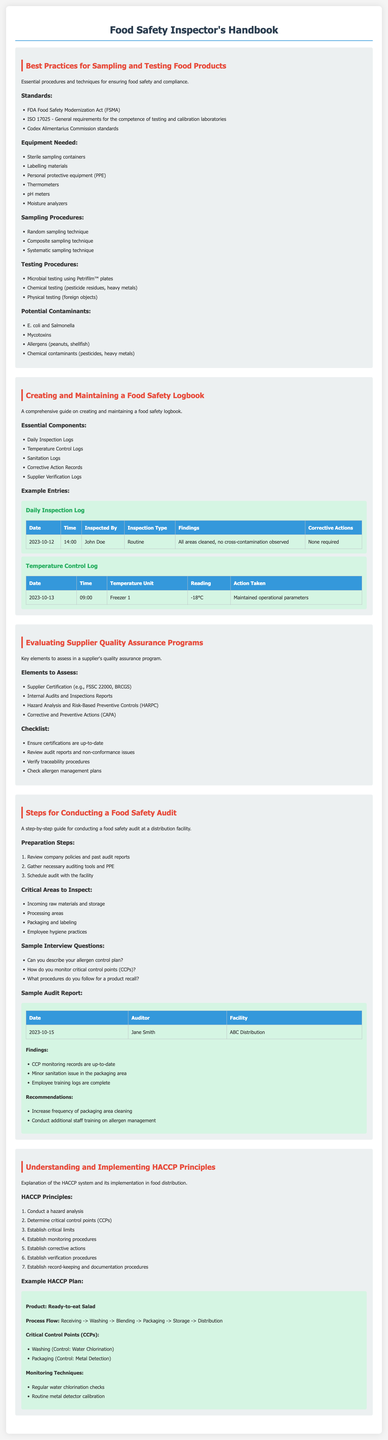What are the standards for sampling and testing food products? The standards are listed in a specific section of the document and include FDA Food Safety Modernization Act (FSMA), ISO 17025, and Codex Alimentarius Commission standards.
Answer: FDA Food Safety Modernization Act (FSMA), ISO 17025, Codex Alimentarius Commission standards What is an example of a critical control point in a HACCP plan for a ready-to-eat salad? The document provides a specific example of critical control points that include washing and packaging.
Answer: Washing What type of logs are included in the food safety logbook? The essential components for the food safety logbook are mentioned in a list.
Answer: Daily Inspection Logs, Temperature Control Logs, Sanitation Logs, Corrective Action Records, Supplier Verification Logs What equipment is needed for sampling food products? The document outlines necessary equipment in a list format, which includes sterile containers and PPE.
Answer: Sterile sampling containers, Labelling materials, Personal protective equipment (PPE) How many principles are there in the HACCP system? The document lists the number of principles as part of the HACCP explanation section.
Answer: Seven 